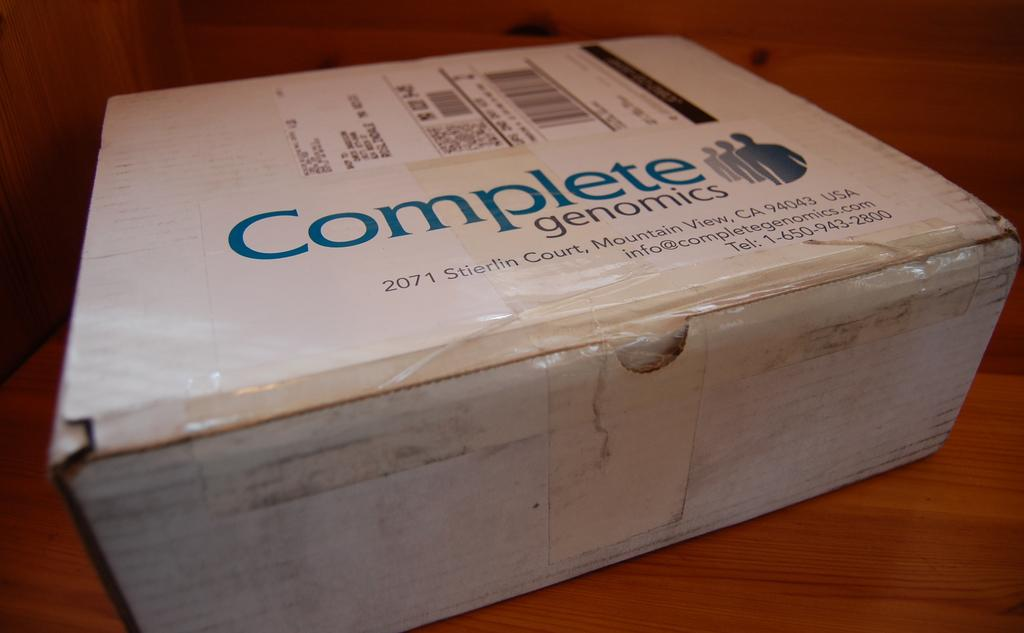<image>
Summarize the visual content of the image. A package from Complete genomics in Mountain View, California. 